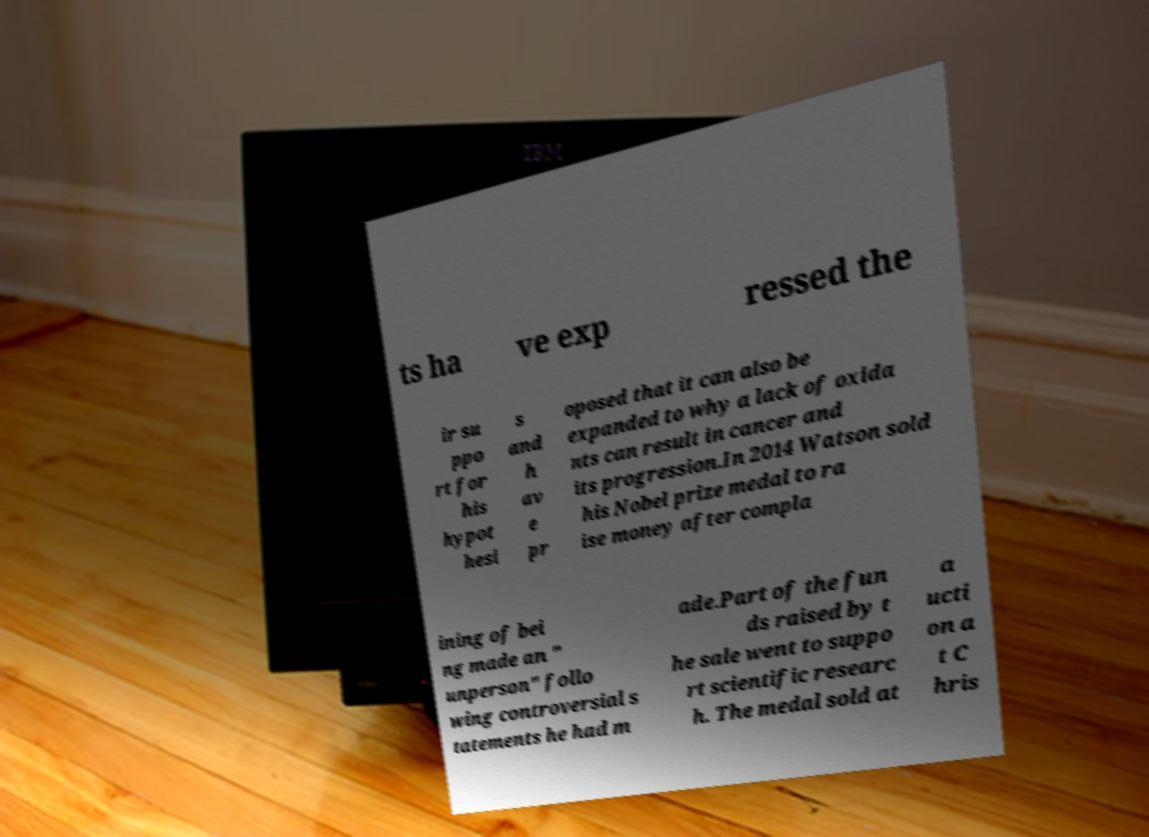Could you assist in decoding the text presented in this image and type it out clearly? ts ha ve exp ressed the ir su ppo rt for his hypot hesi s and h av e pr oposed that it can also be expanded to why a lack of oxida nts can result in cancer and its progression.In 2014 Watson sold his Nobel prize medal to ra ise money after compla ining of bei ng made an " unperson" follo wing controversial s tatements he had m ade.Part of the fun ds raised by t he sale went to suppo rt scientific researc h. The medal sold at a ucti on a t C hris 